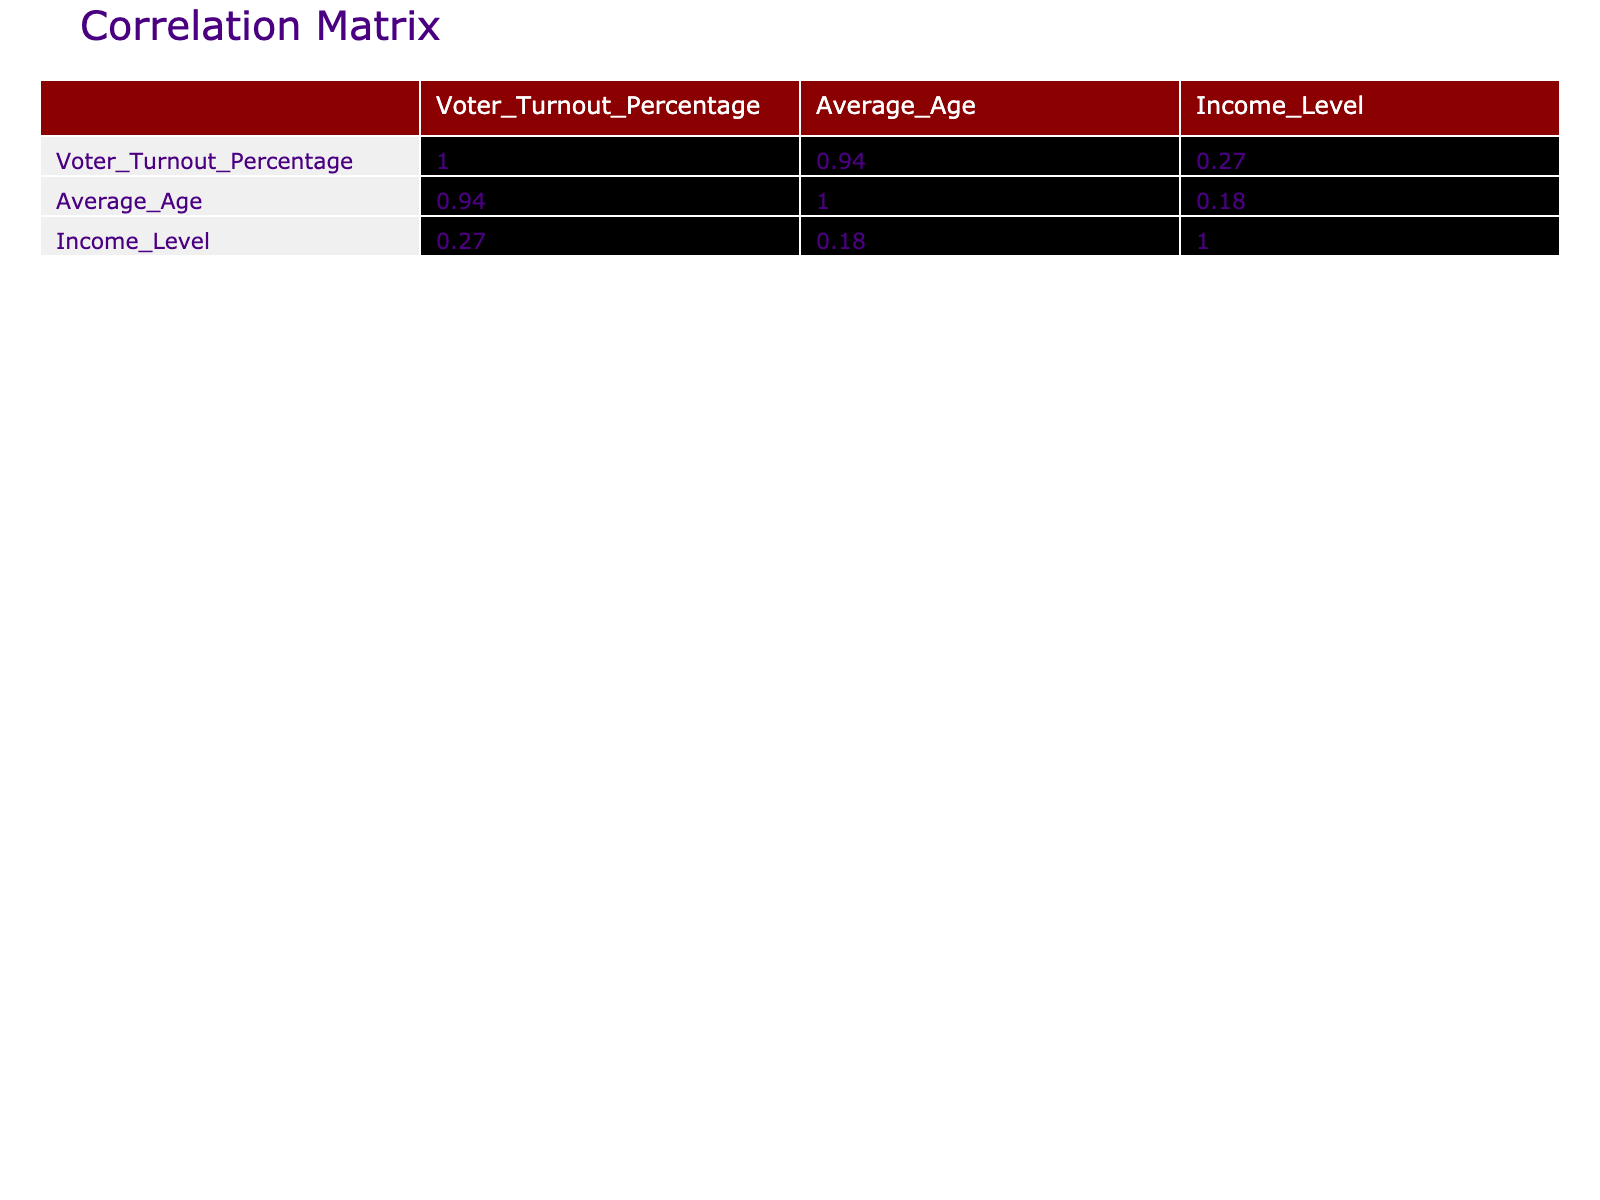What is the voter turnout percentage for Senior Voters (65+)? The table lists the demographic groups along with their respective voter turnout percentages. Looking at the row for Senior Voters (65+), the voter turnout percentage is clearly stated as 75.0%.
Answer: 75.0% Which demographic group has the highest average age? By examining the 'Average_Age' values for each demographic group in the table, we can see that Senior Voters (65+) have the highest average age of 70.
Answer: 70 What is the correlation between Education Level and Voter Turnout Percentage? Education Level is categorized as a nominal variable and is not represented with numerical values in the correlation matrix, meaning that no quantitative correlation can be calculated for it in this scenario. Therefore, the question does not apply.
Answer: Not applicable How does the voter turnout for Young Voters (18-29) compare to that of White voters? The table shows that the voter turnout percentage for Young Voters (18-29) is 45.0%, while for White voters, it is 66.0%. Comparing these two values, White voters had a higher voter turnout by 21%.
Answer: 21% Is the average age higher for men compared to women? The average age for Men is 51, while for Women, it is 49. Since 51 is greater than 49, we confirm that the average age for men is indeed higher than that for women.
Answer: Yes What is the difference in income levels between African Americans and Native Americans? The income level for African Americans is $45,000 and for Native Americans is $35,000. To find the difference, we subtract $35,000 from $45,000, yielding $10,000.
Answer: 10000 Which demographic groups have urbanization levels classified as "Urban"? The demographic groups listed as "Urban" are African American, White, Asian, and Men. These can be found by reviewing the 'Urbanization_Level' column where "Urban" is specified.
Answer: African American, White, Asian, Men What is the average voter turnout percentage for demographic groups with a College Degree? The groups with a College Degree are African American, White, Women, Men, and Middle-Aged Voters (30-44). Their respective turnout percentages are 56.0%, 66.0%, 58.0%, 62.0%, and 58.0%. Adding these together gives 56 + 66 + 58 + 62 + 58 = 300. Dividing this sum by the number of groups, which is 5, the average voter turnout percentage is 300 / 5 = 60.0%.
Answer: 60.0% 